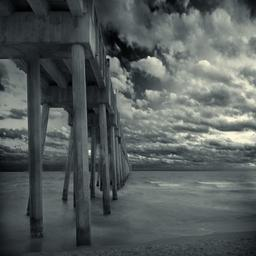What time of day does it appear to be in the image? The image suggests late afternoon or early evening, judging by the softness and angle of the light, which casts long shadows and gives the clouds a soft, diffuse appearance. The subdued lighting adds a calm and serene atmosphere to the scene. 